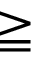Convert formula to latex. <formula><loc_0><loc_0><loc_500><loc_500>\geqq</formula> 